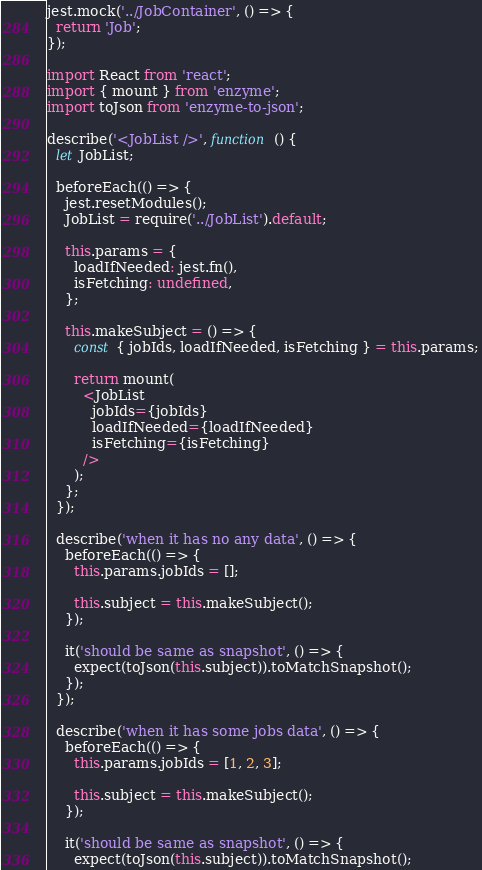Convert code to text. <code><loc_0><loc_0><loc_500><loc_500><_JavaScript_>jest.mock('../JobContainer', () => {
  return 'Job';
});

import React from 'react';
import { mount } from 'enzyme';
import toJson from 'enzyme-to-json';

describe('<JobList />', function () {
  let JobList;

  beforeEach(() => {
    jest.resetModules();
    JobList = require('../JobList').default;

    this.params = {
      loadIfNeeded: jest.fn(),
      isFetching: undefined,
    };

    this.makeSubject = () => {
      const { jobIds, loadIfNeeded, isFetching } = this.params;

      return mount(
        <JobList
          jobIds={jobIds}
          loadIfNeeded={loadIfNeeded}
          isFetching={isFetching}
        />
      );
    };
  });

  describe('when it has no any data', () => {
    beforeEach(() => {
      this.params.jobIds = [];

      this.subject = this.makeSubject();
    });

    it('should be same as snapshot', () => {
      expect(toJson(this.subject)).toMatchSnapshot();
    });
  });

  describe('when it has some jobs data', () => {
    beforeEach(() => {
      this.params.jobIds = [1, 2, 3];

      this.subject = this.makeSubject();
    });

    it('should be same as snapshot', () => {
      expect(toJson(this.subject)).toMatchSnapshot();</code> 